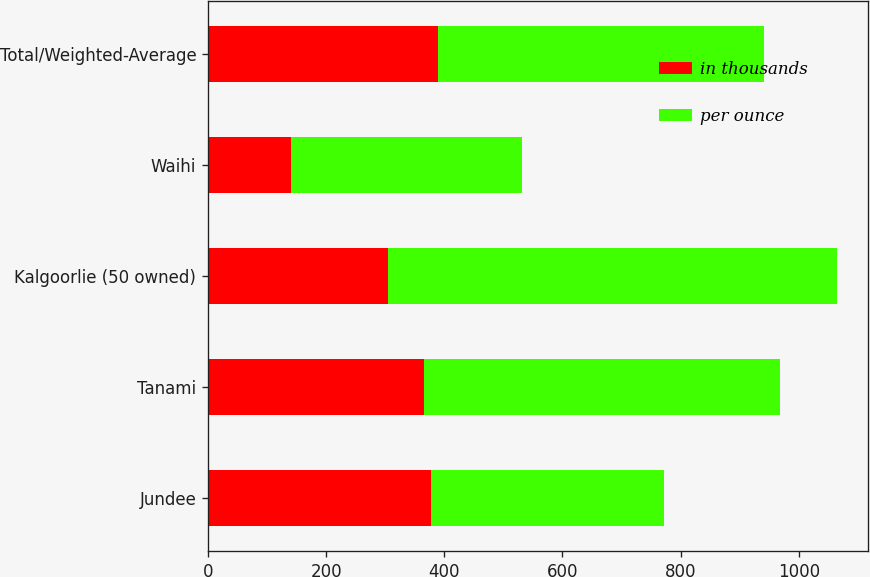Convert chart. <chart><loc_0><loc_0><loc_500><loc_500><stacked_bar_chart><ecel><fcel>Jundee<fcel>Tanami<fcel>Kalgoorlie (50 owned)<fcel>Waihi<fcel>Total/Weighted-Average<nl><fcel>in thousands<fcel>377<fcel>365<fcel>304<fcel>141<fcel>390<nl><fcel>per ounce<fcel>395<fcel>604<fcel>760<fcel>390<fcel>552<nl></chart> 